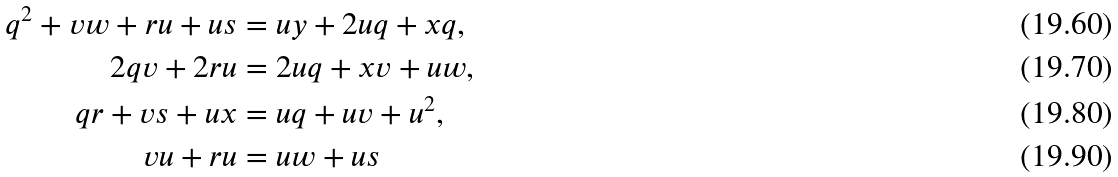Convert formula to latex. <formula><loc_0><loc_0><loc_500><loc_500>q ^ { 2 } + v w + r u + u s & = u y + 2 u q + x q , \\ 2 q v + 2 r u & = 2 u q + x v + u w , \\ q r + v s + u x & = u q + u v + u ^ { 2 } , \\ v u + r u & = u w + u s</formula> 